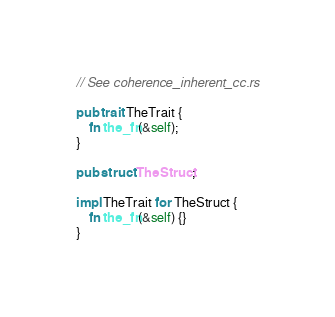<code> <loc_0><loc_0><loc_500><loc_500><_Rust_>// See coherence_inherent_cc.rs

pub trait TheTrait {
    fn the_fn(&self);
}

pub struct TheStruct;

impl TheTrait for TheStruct {
    fn the_fn(&self) {}
}
</code> 